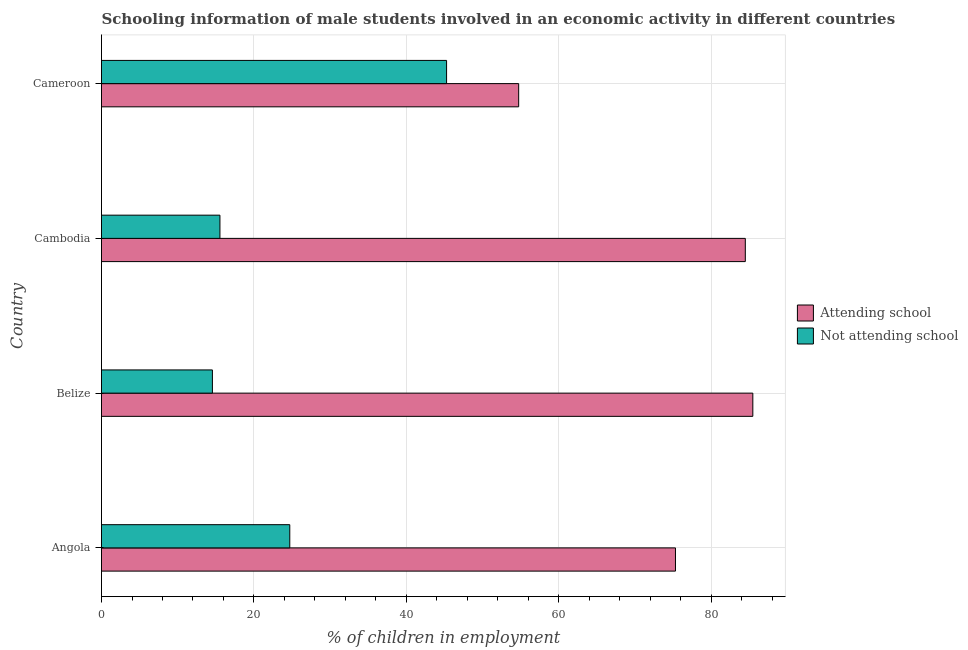How many different coloured bars are there?
Your answer should be compact. 2. How many groups of bars are there?
Give a very brief answer. 4. Are the number of bars per tick equal to the number of legend labels?
Provide a succinct answer. Yes. Are the number of bars on each tick of the Y-axis equal?
Offer a very short reply. Yes. How many bars are there on the 1st tick from the bottom?
Provide a succinct answer. 2. What is the label of the 3rd group of bars from the top?
Offer a terse response. Belize. What is the percentage of employed males who are attending school in Angola?
Keep it short and to the point. 75.3. Across all countries, what is the maximum percentage of employed males who are not attending school?
Make the answer very short. 45.27. Across all countries, what is the minimum percentage of employed males who are attending school?
Provide a short and direct response. 54.73. In which country was the percentage of employed males who are not attending school maximum?
Your answer should be compact. Cameroon. In which country was the percentage of employed males who are not attending school minimum?
Offer a very short reply. Belize. What is the total percentage of employed males who are not attending school in the graph?
Your answer should be compact. 100.06. What is the difference between the percentage of employed males who are attending school in Angola and that in Cambodia?
Your answer should be very brief. -9.16. What is the difference between the percentage of employed males who are not attending school in Angola and the percentage of employed males who are attending school in Cameroon?
Your answer should be very brief. -30.03. What is the average percentage of employed males who are attending school per country?
Your response must be concise. 74.99. What is the difference between the percentage of employed males who are attending school and percentage of employed males who are not attending school in Cameroon?
Provide a short and direct response. 9.46. In how many countries, is the percentage of employed males who are attending school greater than 40 %?
Your answer should be very brief. 4. What is the ratio of the percentage of employed males who are not attending school in Belize to that in Cambodia?
Make the answer very short. 0.94. Is the percentage of employed males who are attending school in Belize less than that in Cambodia?
Keep it short and to the point. No. Is the difference between the percentage of employed males who are attending school in Belize and Cameroon greater than the difference between the percentage of employed males who are not attending school in Belize and Cameroon?
Keep it short and to the point. Yes. What is the difference between the highest and the second highest percentage of employed males who are attending school?
Offer a terse response. 0.99. What is the difference between the highest and the lowest percentage of employed males who are attending school?
Offer a terse response. 30.72. Is the sum of the percentage of employed males who are not attending school in Angola and Belize greater than the maximum percentage of employed males who are attending school across all countries?
Your response must be concise. No. What does the 2nd bar from the top in Belize represents?
Provide a short and direct response. Attending school. What does the 2nd bar from the bottom in Cambodia represents?
Your response must be concise. Not attending school. Are all the bars in the graph horizontal?
Make the answer very short. Yes. Are the values on the major ticks of X-axis written in scientific E-notation?
Give a very brief answer. No. Does the graph contain any zero values?
Give a very brief answer. No. Does the graph contain grids?
Keep it short and to the point. Yes. How are the legend labels stacked?
Your answer should be compact. Vertical. What is the title of the graph?
Give a very brief answer. Schooling information of male students involved in an economic activity in different countries. Does "Long-term debt" appear as one of the legend labels in the graph?
Give a very brief answer. No. What is the label or title of the X-axis?
Your answer should be compact. % of children in employment. What is the % of children in employment in Attending school in Angola?
Give a very brief answer. 75.3. What is the % of children in employment of Not attending school in Angola?
Give a very brief answer. 24.7. What is the % of children in employment of Attending school in Belize?
Keep it short and to the point. 85.45. What is the % of children in employment of Not attending school in Belize?
Make the answer very short. 14.55. What is the % of children in employment of Attending school in Cambodia?
Ensure brevity in your answer.  84.46. What is the % of children in employment in Not attending school in Cambodia?
Your answer should be very brief. 15.54. What is the % of children in employment in Attending school in Cameroon?
Offer a very short reply. 54.73. What is the % of children in employment of Not attending school in Cameroon?
Ensure brevity in your answer.  45.27. Across all countries, what is the maximum % of children in employment in Attending school?
Offer a terse response. 85.45. Across all countries, what is the maximum % of children in employment of Not attending school?
Keep it short and to the point. 45.27. Across all countries, what is the minimum % of children in employment in Attending school?
Your answer should be compact. 54.73. Across all countries, what is the minimum % of children in employment in Not attending school?
Ensure brevity in your answer.  14.55. What is the total % of children in employment in Attending school in the graph?
Offer a terse response. 299.94. What is the total % of children in employment in Not attending school in the graph?
Ensure brevity in your answer.  100.06. What is the difference between the % of children in employment in Attending school in Angola and that in Belize?
Offer a very short reply. -10.15. What is the difference between the % of children in employment in Not attending school in Angola and that in Belize?
Keep it short and to the point. 10.15. What is the difference between the % of children in employment in Attending school in Angola and that in Cambodia?
Offer a very short reply. -9.16. What is the difference between the % of children in employment in Not attending school in Angola and that in Cambodia?
Offer a very short reply. 9.16. What is the difference between the % of children in employment of Attending school in Angola and that in Cameroon?
Your answer should be very brief. 20.57. What is the difference between the % of children in employment of Not attending school in Angola and that in Cameroon?
Your answer should be compact. -20.57. What is the difference between the % of children in employment of Attending school in Belize and that in Cambodia?
Give a very brief answer. 0.99. What is the difference between the % of children in employment in Not attending school in Belize and that in Cambodia?
Your response must be concise. -0.99. What is the difference between the % of children in employment of Attending school in Belize and that in Cameroon?
Give a very brief answer. 30.72. What is the difference between the % of children in employment in Not attending school in Belize and that in Cameroon?
Offer a terse response. -30.72. What is the difference between the % of children in employment of Attending school in Cambodia and that in Cameroon?
Offer a terse response. 29.73. What is the difference between the % of children in employment in Not attending school in Cambodia and that in Cameroon?
Ensure brevity in your answer.  -29.73. What is the difference between the % of children in employment in Attending school in Angola and the % of children in employment in Not attending school in Belize?
Ensure brevity in your answer.  60.75. What is the difference between the % of children in employment of Attending school in Angola and the % of children in employment of Not attending school in Cambodia?
Offer a terse response. 59.76. What is the difference between the % of children in employment in Attending school in Angola and the % of children in employment in Not attending school in Cameroon?
Ensure brevity in your answer.  30.03. What is the difference between the % of children in employment in Attending school in Belize and the % of children in employment in Not attending school in Cambodia?
Your answer should be very brief. 69.91. What is the difference between the % of children in employment of Attending school in Belize and the % of children in employment of Not attending school in Cameroon?
Provide a succinct answer. 40.18. What is the difference between the % of children in employment in Attending school in Cambodia and the % of children in employment in Not attending school in Cameroon?
Keep it short and to the point. 39.19. What is the average % of children in employment in Attending school per country?
Keep it short and to the point. 74.99. What is the average % of children in employment of Not attending school per country?
Offer a terse response. 25.01. What is the difference between the % of children in employment in Attending school and % of children in employment in Not attending school in Angola?
Provide a succinct answer. 50.6. What is the difference between the % of children in employment in Attending school and % of children in employment in Not attending school in Belize?
Your response must be concise. 70.9. What is the difference between the % of children in employment in Attending school and % of children in employment in Not attending school in Cambodia?
Offer a very short reply. 68.93. What is the difference between the % of children in employment of Attending school and % of children in employment of Not attending school in Cameroon?
Your response must be concise. 9.46. What is the ratio of the % of children in employment of Attending school in Angola to that in Belize?
Give a very brief answer. 0.88. What is the ratio of the % of children in employment in Not attending school in Angola to that in Belize?
Your answer should be compact. 1.7. What is the ratio of the % of children in employment of Attending school in Angola to that in Cambodia?
Your answer should be very brief. 0.89. What is the ratio of the % of children in employment of Not attending school in Angola to that in Cambodia?
Your answer should be very brief. 1.59. What is the ratio of the % of children in employment in Attending school in Angola to that in Cameroon?
Offer a terse response. 1.38. What is the ratio of the % of children in employment of Not attending school in Angola to that in Cameroon?
Give a very brief answer. 0.55. What is the ratio of the % of children in employment in Attending school in Belize to that in Cambodia?
Offer a terse response. 1.01. What is the ratio of the % of children in employment in Not attending school in Belize to that in Cambodia?
Your answer should be compact. 0.94. What is the ratio of the % of children in employment in Attending school in Belize to that in Cameroon?
Keep it short and to the point. 1.56. What is the ratio of the % of children in employment of Not attending school in Belize to that in Cameroon?
Your response must be concise. 0.32. What is the ratio of the % of children in employment in Attending school in Cambodia to that in Cameroon?
Your response must be concise. 1.54. What is the ratio of the % of children in employment in Not attending school in Cambodia to that in Cameroon?
Keep it short and to the point. 0.34. What is the difference between the highest and the second highest % of children in employment of Attending school?
Your answer should be compact. 0.99. What is the difference between the highest and the second highest % of children in employment of Not attending school?
Make the answer very short. 20.57. What is the difference between the highest and the lowest % of children in employment of Attending school?
Make the answer very short. 30.72. What is the difference between the highest and the lowest % of children in employment in Not attending school?
Keep it short and to the point. 30.72. 